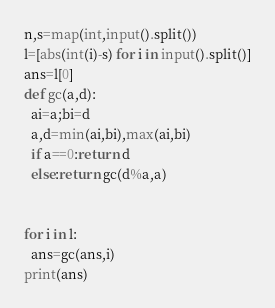<code> <loc_0><loc_0><loc_500><loc_500><_Python_>n,s=map(int,input().split())
l=[abs(int(i)-s) for i in input().split()]
ans=l[0]
def gc(a,d):
  ai=a;bi=d
  a,d=min(ai,bi),max(ai,bi)
  if a==0:return d
  else:return gc(d%a,a)
  
  
for i in l:
  ans=gc(ans,i)
print(ans)</code> 